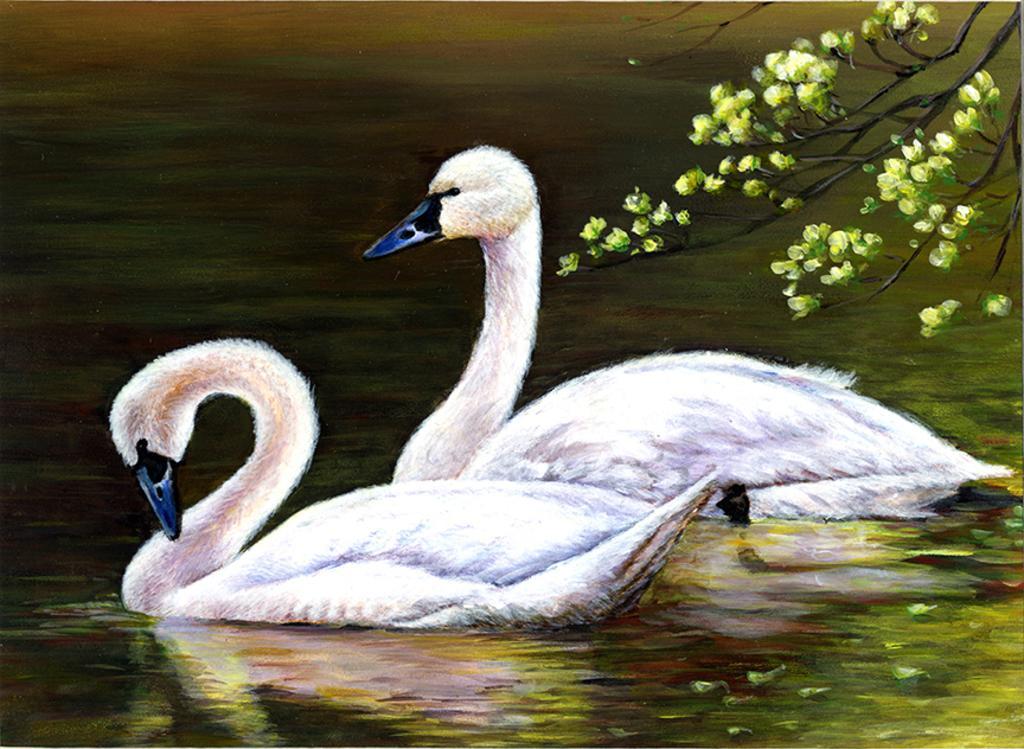Describe this image in one or two sentences. This image looks like an edited photo in which I can see two swans in the water and trees. 